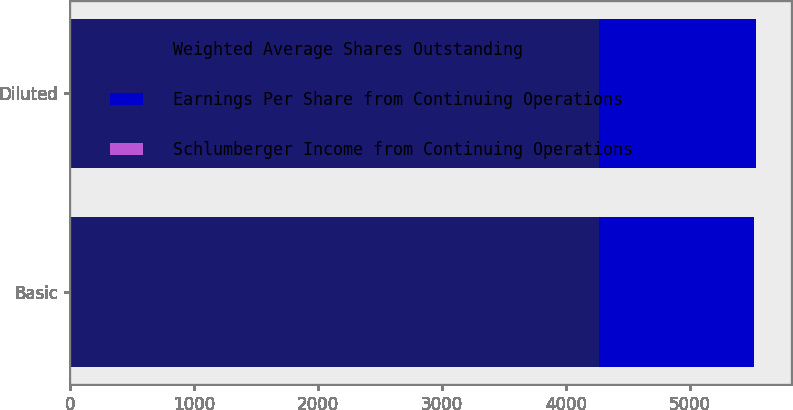Convert chart to OTSL. <chart><loc_0><loc_0><loc_500><loc_500><stacked_bar_chart><ecel><fcel>Basic<fcel>Diluted<nl><fcel>Weighted Average Shares Outstanding<fcel>4267<fcel>4270<nl><fcel>Earnings Per Share from Continuing Operations<fcel>1250<fcel>1263<nl><fcel>Schlumberger Income from Continuing Operations<fcel>3.41<fcel>3.38<nl></chart> 